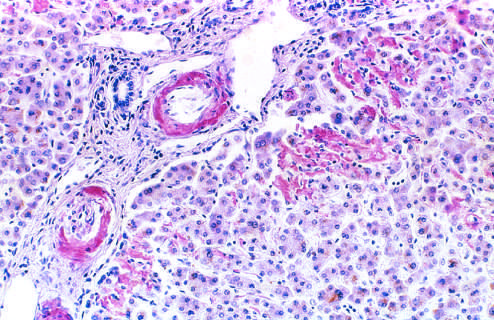does a section of liver stained with congo red reveal pink-red deposits of amyloid in the walls of blood vessels and along sinusoids?
Answer the question using a single word or phrase. Yes 